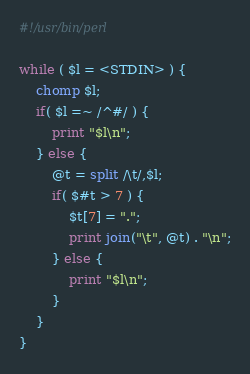Convert code to text. <code><loc_0><loc_0><loc_500><loc_500><_Perl_>#!/usr/bin/perl

while ( $l = <STDIN> ) {
	chomp $l;
	if( $l =~ /^#/ ) { 
		print "$l\n"; 
	} else {
		@t = split /\t/,$l;
		if( $#t > 7 ) {
			$t[7] = ".";
			print join("\t", @t) . "\n";
		} else {
			print "$l\n"; 
		}
	}
}
</code> 